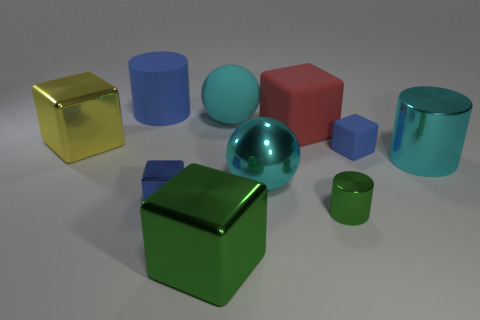What can you tell me about the material of the objects? The objects in the image have surfaces that appear smooth and reflective, suggesting they are made of a metallic or glossy material, giving them a sleek and polished finish.  How would you describe the shapes present in the scene? The scene includes a variety of geometric shapes: cubes that have six square faces, cylinders with two circular bases and one curved side, and a sphere which is perfectly round in every direction. 